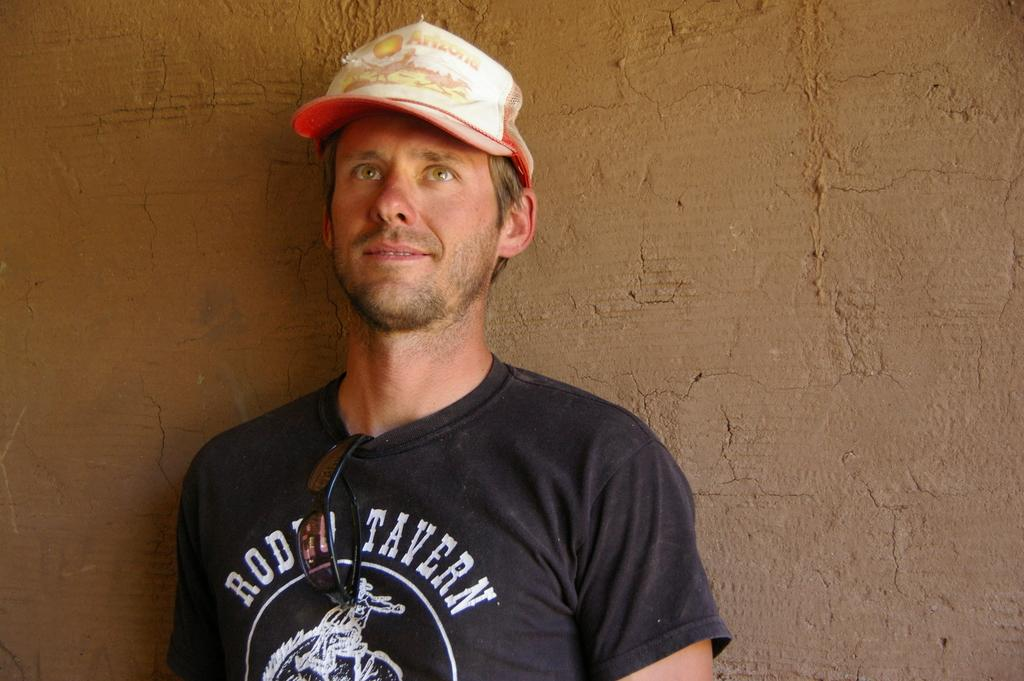<image>
Give a short and clear explanation of the subsequent image. A man wears an old hat that he likely got in Arizona. 